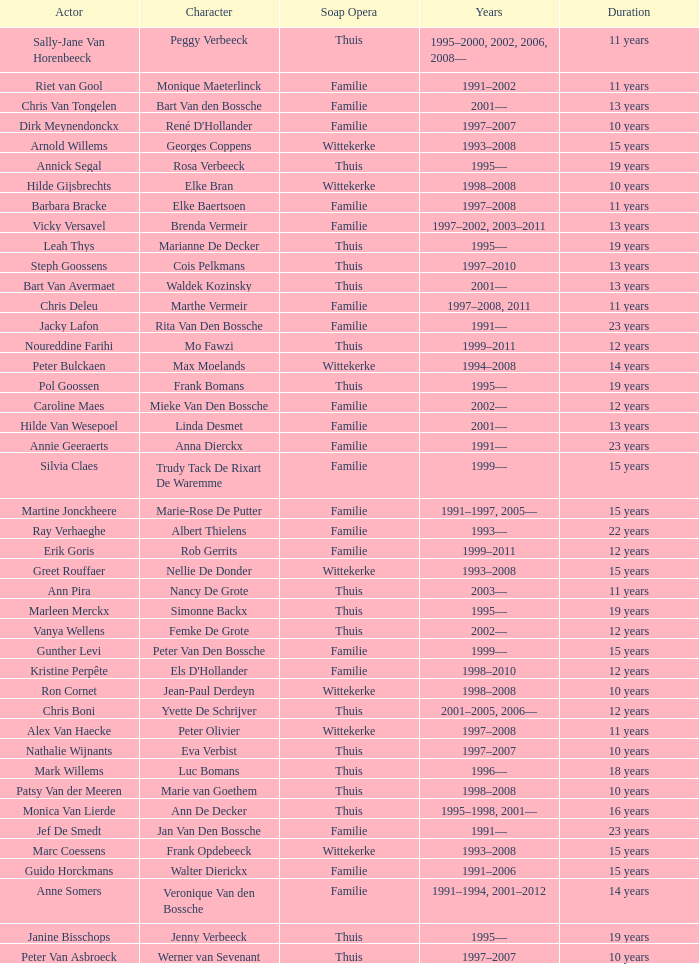What character did Vicky Versavel play for 13 years? Brenda Vermeir. 